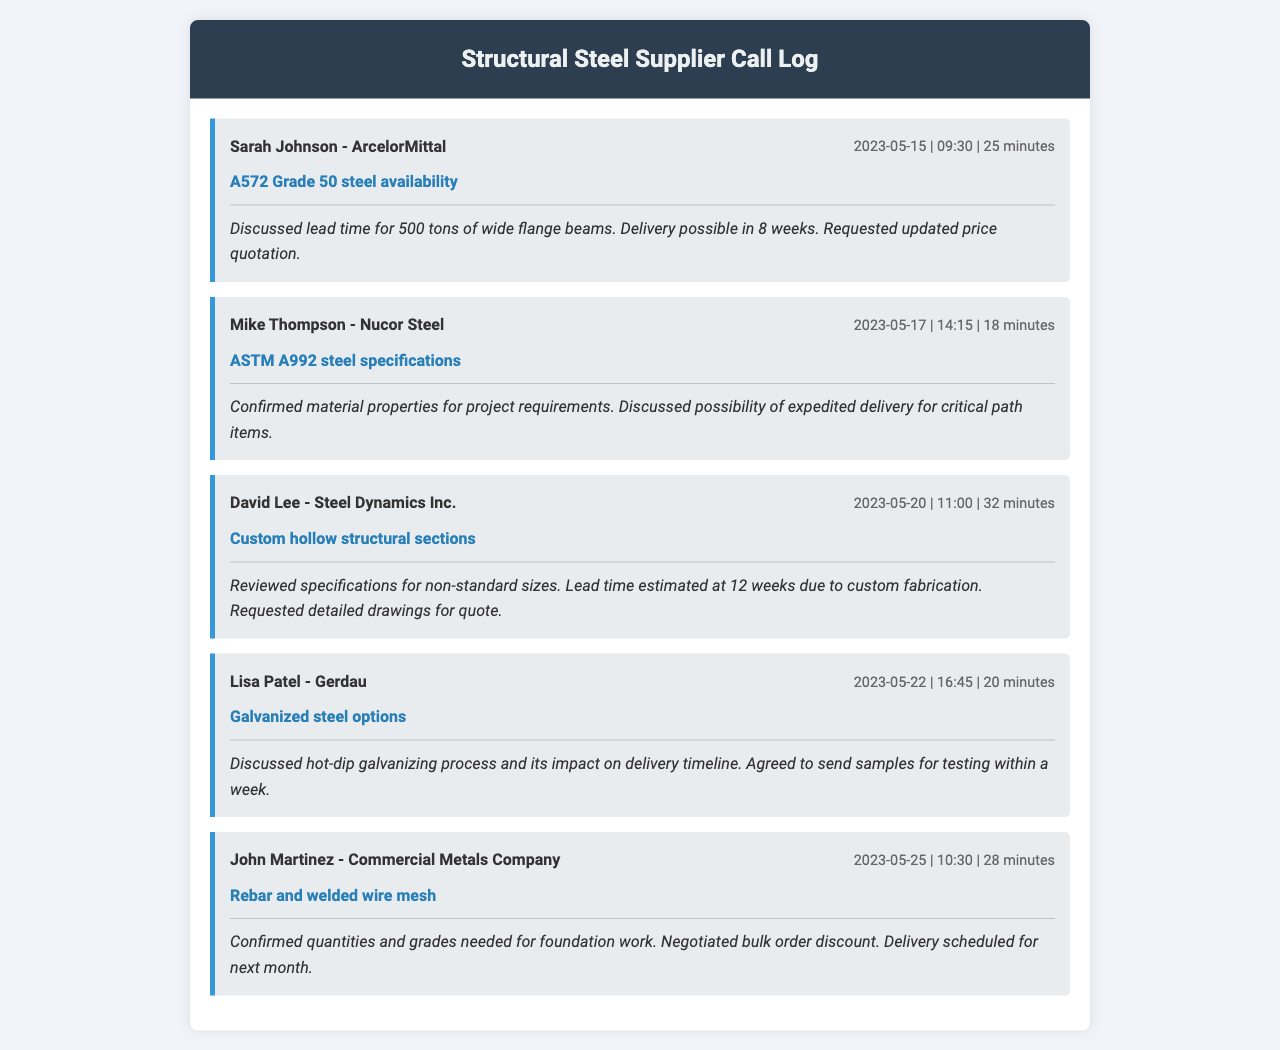What is the date of the call with Sarah Johnson? The date of the call with Sarah Johnson can be found in the call entry, which is 2023-05-15.
Answer: 2023-05-15 How long was the call with Mike Thompson? The duration of the call with Mike Thompson is specified in the call details, which is 18 minutes.
Answer: 18 minutes What was discussed in the call with Lisa Patel? The call entry provides information on the topic discussed with Lisa Patel, which is galvanized steel options.
Answer: Galvanized steel options What is the estimated lead time for custom hollow structural sections? The lead time for custom hollow structural sections is mentioned in the notes for David Lee's call, which is 12 weeks.
Answer: 12 weeks Did John Martinez confirm quantities for rebar? The call note for John Martinez's entry states that he confirmed quantities and grades needed for foundation work.
Answer: Yes What contact company is associated with David Lee? The company associated with David Lee can be found in the call header, which is Steel Dynamics Inc.
Answer: Steel Dynamics Inc How many tons of wide flange beams were discussed in the first call? The call notes indicate that the discussion involved 500 tons of wide flange beams.
Answer: 500 tons What process was discussed in the call with Lisa Patel that impacts delivery? The discussion involved the hot-dip galvanizing process and its impact on delivery timeline.
Answer: Hot-dip galvanizing process 